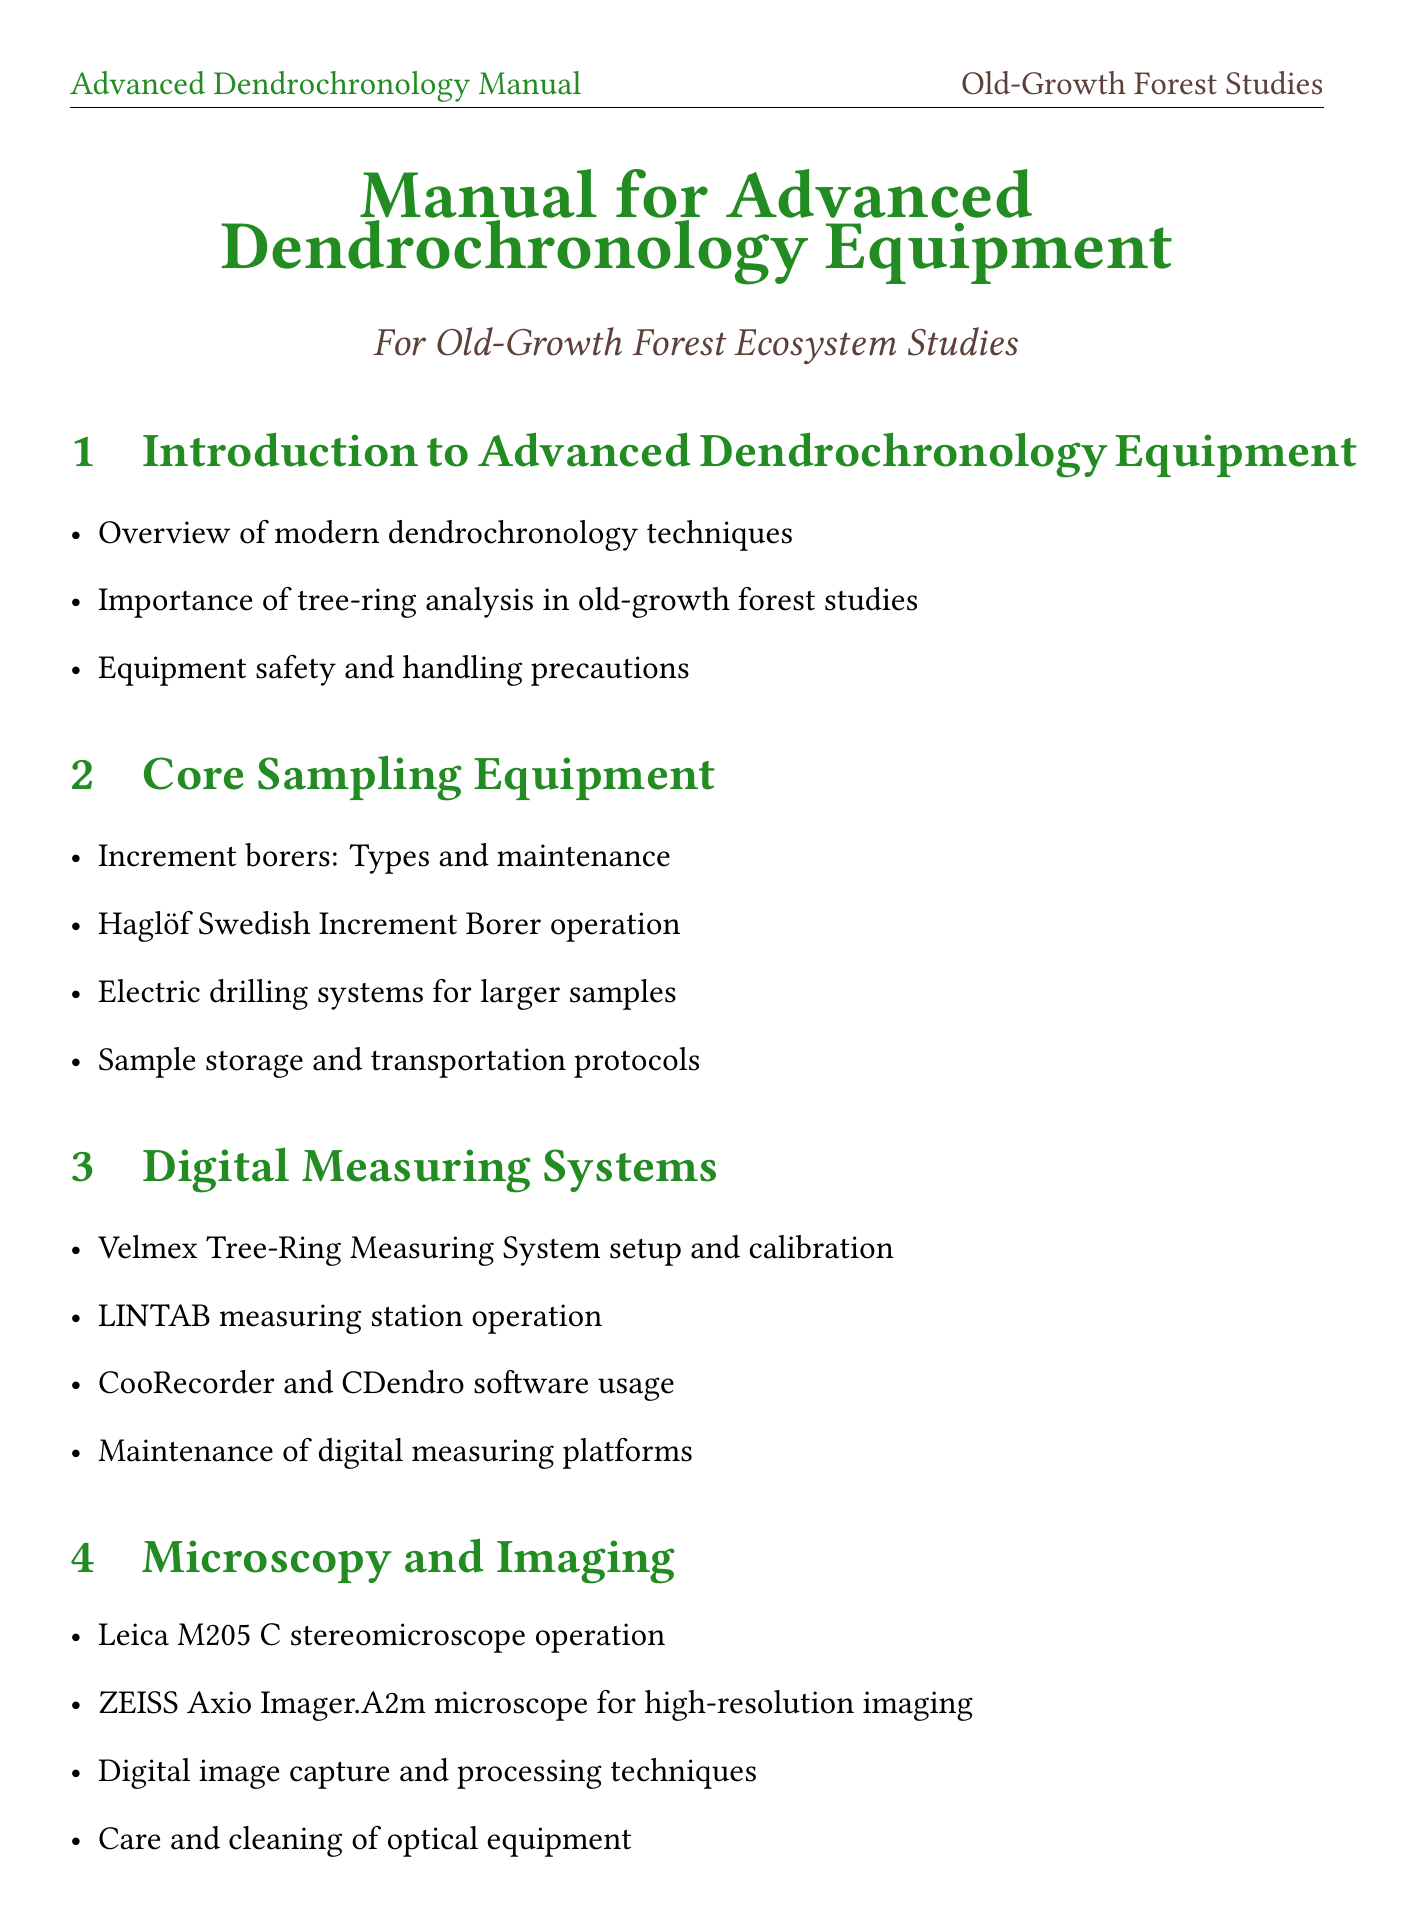What is the title of the manual? The title of the manual is the first piece of information presented in the document, outlining its focus on advanced dendrochronology.
Answer: Manual for Advanced Dendrochronology Equipment How many sections are in the manual? The number of sections provides an overview of the manual's structure, which is important for navigation.
Answer: Ten What equipment is covered under the Core Sampling Equipment section? The Core Sampling Equipment section explicitly lists types of equipment used for sampling, indicating what is discussed.
Answer: Increment borers What does COFECHA stand for? Understanding the acronym helps in recognizing methods discussed in the Tree-Ring Analysis Techniques section.
Answer: COFECHA Which software is mentioned for dendrochronological analysis? This identifies the specific tools referenced for data analysis, which can be essential for practical applications.
Answer: Tellervo What microscope model is used for high-resolution imaging? This question seeks to identify specific equipment used in microscopy, a key area in the manual.
Answer: ZEISS Axio Imager.A2m What is the main focus of Section 9? Knowing the main topic of this section reveals its relevance to ecological and ethical considerations in research.
Answer: Ecosystem Considerations in Old-Growth Forests What technique is used for statistical cross-dating? This asks about a specific technique mentioned to understand its relevance to dendrochronology.
Answer: COFECHA What is the purpose of battery management in Field Equipment Maintenance? This question identifies the rationale behind equipment upkeep, linking practical maintenance to operational efficiency.
Answer: For electronic devices How frequently should calibration and testing procedures be performed? This addresses the maintenance routine critical for ensuring the accuracy of field equipment.
Answer: Annually 